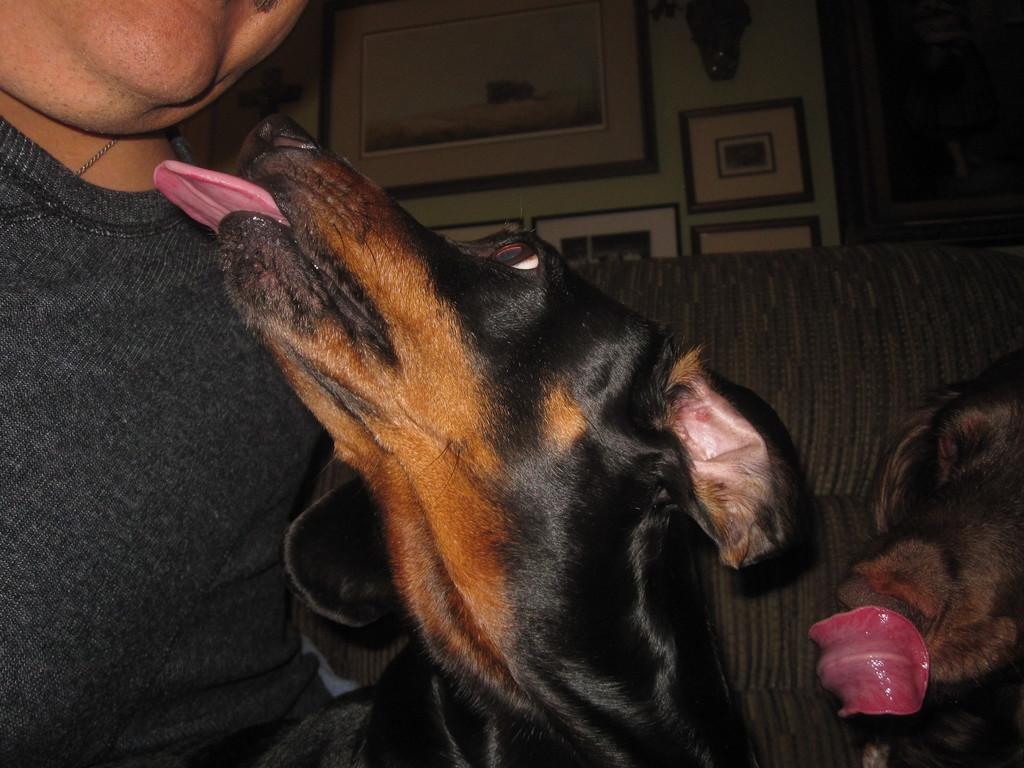How would you summarize this image in a sentence or two? In this image I can see a person and two dogs. At the back of these there is a couch. At the top of the image there are few frames attached to the wall. 